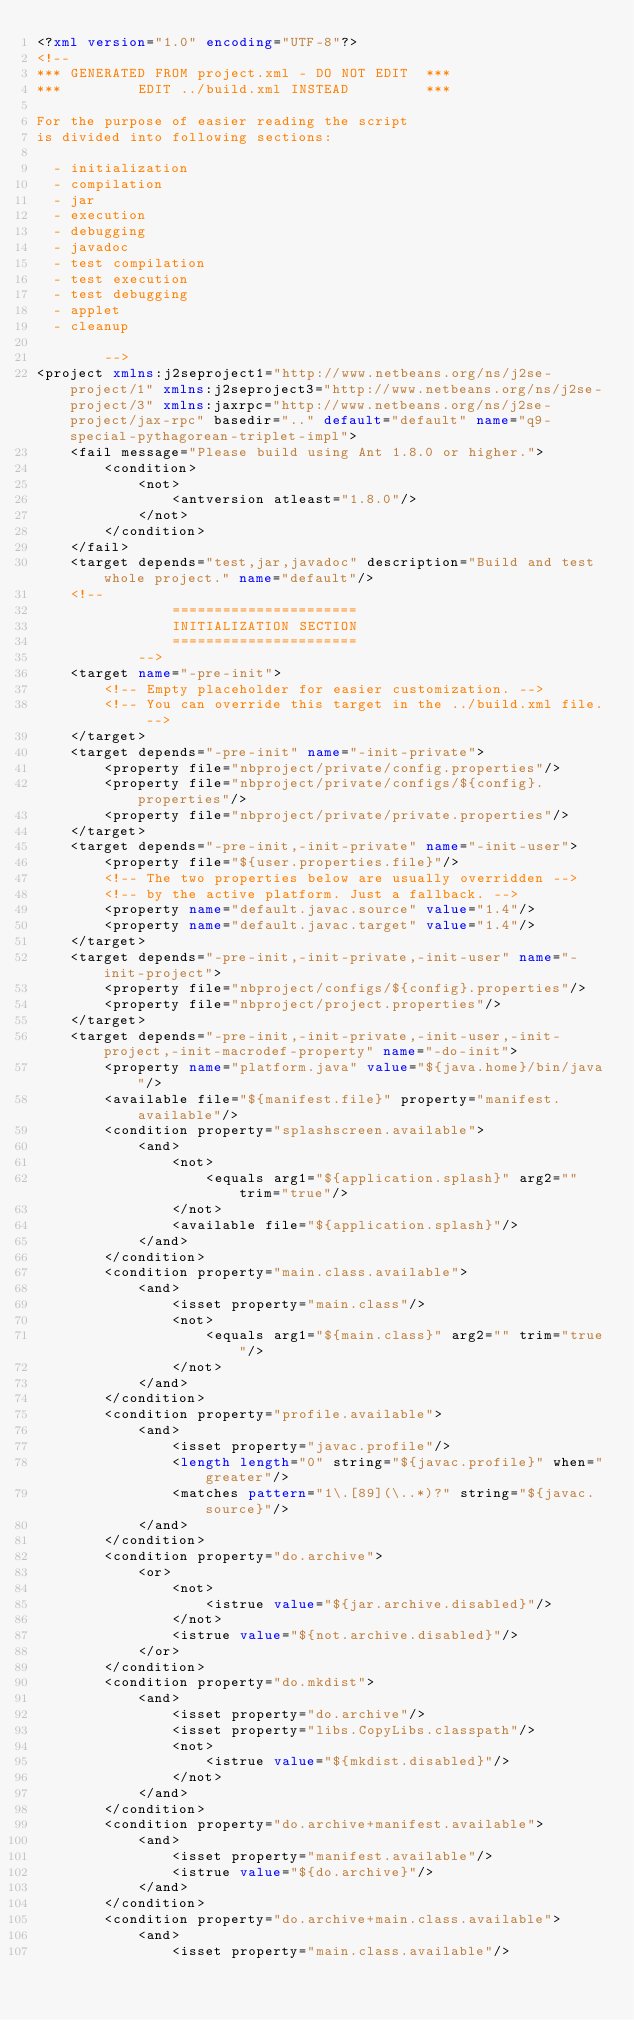Convert code to text. <code><loc_0><loc_0><loc_500><loc_500><_XML_><?xml version="1.0" encoding="UTF-8"?>
<!--
*** GENERATED FROM project.xml - DO NOT EDIT  ***
***         EDIT ../build.xml INSTEAD         ***

For the purpose of easier reading the script
is divided into following sections:

  - initialization
  - compilation
  - jar
  - execution
  - debugging
  - javadoc
  - test compilation
  - test execution
  - test debugging
  - applet
  - cleanup

        -->
<project xmlns:j2seproject1="http://www.netbeans.org/ns/j2se-project/1" xmlns:j2seproject3="http://www.netbeans.org/ns/j2se-project/3" xmlns:jaxrpc="http://www.netbeans.org/ns/j2se-project/jax-rpc" basedir=".." default="default" name="q9-special-pythagorean-triplet-impl">
    <fail message="Please build using Ant 1.8.0 or higher.">
        <condition>
            <not>
                <antversion atleast="1.8.0"/>
            </not>
        </condition>
    </fail>
    <target depends="test,jar,javadoc" description="Build and test whole project." name="default"/>
    <!-- 
                ======================
                INITIALIZATION SECTION 
                ======================
            -->
    <target name="-pre-init">
        <!-- Empty placeholder for easier customization. -->
        <!-- You can override this target in the ../build.xml file. -->
    </target>
    <target depends="-pre-init" name="-init-private">
        <property file="nbproject/private/config.properties"/>
        <property file="nbproject/private/configs/${config}.properties"/>
        <property file="nbproject/private/private.properties"/>
    </target>
    <target depends="-pre-init,-init-private" name="-init-user">
        <property file="${user.properties.file}"/>
        <!-- The two properties below are usually overridden -->
        <!-- by the active platform. Just a fallback. -->
        <property name="default.javac.source" value="1.4"/>
        <property name="default.javac.target" value="1.4"/>
    </target>
    <target depends="-pre-init,-init-private,-init-user" name="-init-project">
        <property file="nbproject/configs/${config}.properties"/>
        <property file="nbproject/project.properties"/>
    </target>
    <target depends="-pre-init,-init-private,-init-user,-init-project,-init-macrodef-property" name="-do-init">
        <property name="platform.java" value="${java.home}/bin/java"/>
        <available file="${manifest.file}" property="manifest.available"/>
        <condition property="splashscreen.available">
            <and>
                <not>
                    <equals arg1="${application.splash}" arg2="" trim="true"/>
                </not>
                <available file="${application.splash}"/>
            </and>
        </condition>
        <condition property="main.class.available">
            <and>
                <isset property="main.class"/>
                <not>
                    <equals arg1="${main.class}" arg2="" trim="true"/>
                </not>
            </and>
        </condition>
        <condition property="profile.available">
            <and>
                <isset property="javac.profile"/>
                <length length="0" string="${javac.profile}" when="greater"/>
                <matches pattern="1\.[89](\..*)?" string="${javac.source}"/>
            </and>
        </condition>
        <condition property="do.archive">
            <or>
                <not>
                    <istrue value="${jar.archive.disabled}"/>
                </not>
                <istrue value="${not.archive.disabled}"/>
            </or>
        </condition>
        <condition property="do.mkdist">
            <and>
                <isset property="do.archive"/>
                <isset property="libs.CopyLibs.classpath"/>
                <not>
                    <istrue value="${mkdist.disabled}"/>
                </not>
            </and>
        </condition>
        <condition property="do.archive+manifest.available">
            <and>
                <isset property="manifest.available"/>
                <istrue value="${do.archive}"/>
            </and>
        </condition>
        <condition property="do.archive+main.class.available">
            <and>
                <isset property="main.class.available"/></code> 